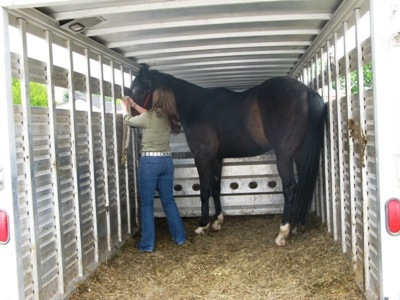Describe the objects in this image and their specific colors. I can see horse in white, black, gray, and darkgray tones and people in white, blue, navy, gray, and black tones in this image. 